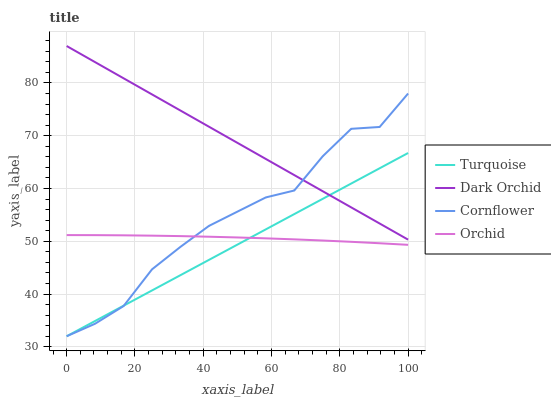Does Turquoise have the minimum area under the curve?
Answer yes or no. Yes. Does Dark Orchid have the maximum area under the curve?
Answer yes or no. Yes. Does Dark Orchid have the minimum area under the curve?
Answer yes or no. No. Does Turquoise have the maximum area under the curve?
Answer yes or no. No. Is Turquoise the smoothest?
Answer yes or no. Yes. Is Cornflower the roughest?
Answer yes or no. Yes. Is Dark Orchid the smoothest?
Answer yes or no. No. Is Dark Orchid the roughest?
Answer yes or no. No. Does Dark Orchid have the lowest value?
Answer yes or no. No. Does Turquoise have the highest value?
Answer yes or no. No. Is Orchid less than Dark Orchid?
Answer yes or no. Yes. Is Dark Orchid greater than Orchid?
Answer yes or no. Yes. Does Orchid intersect Dark Orchid?
Answer yes or no. No. 